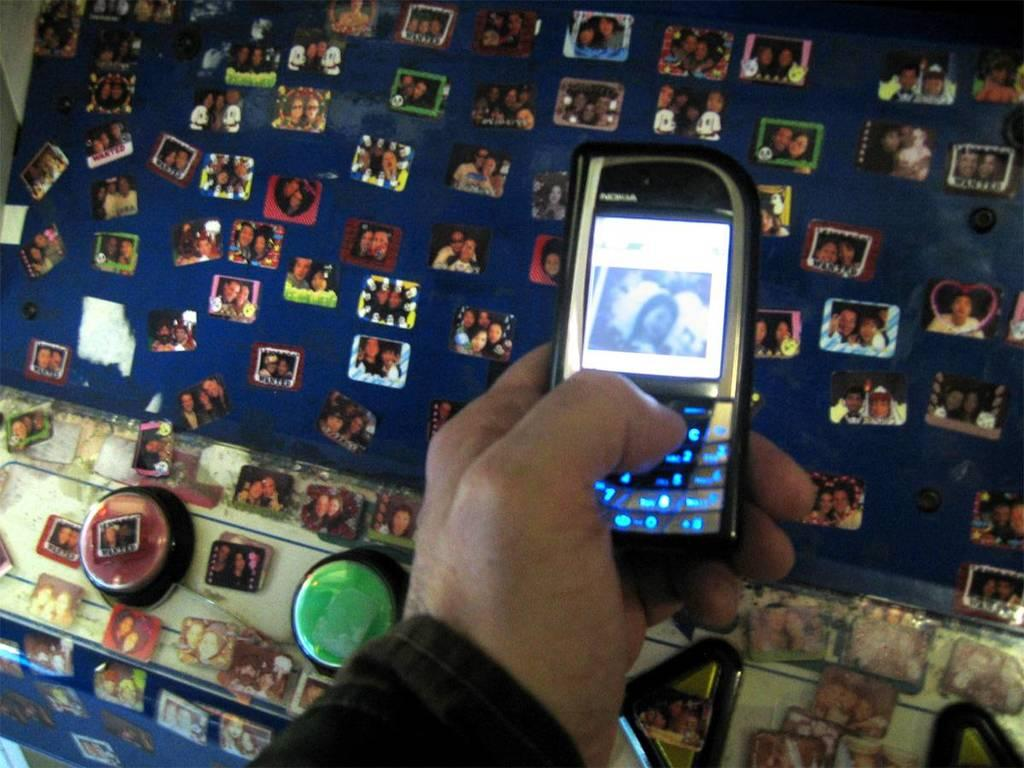<image>
Render a clear and concise summary of the photo. A man is texting on a Nokia phone in front of board filled with photographs. 